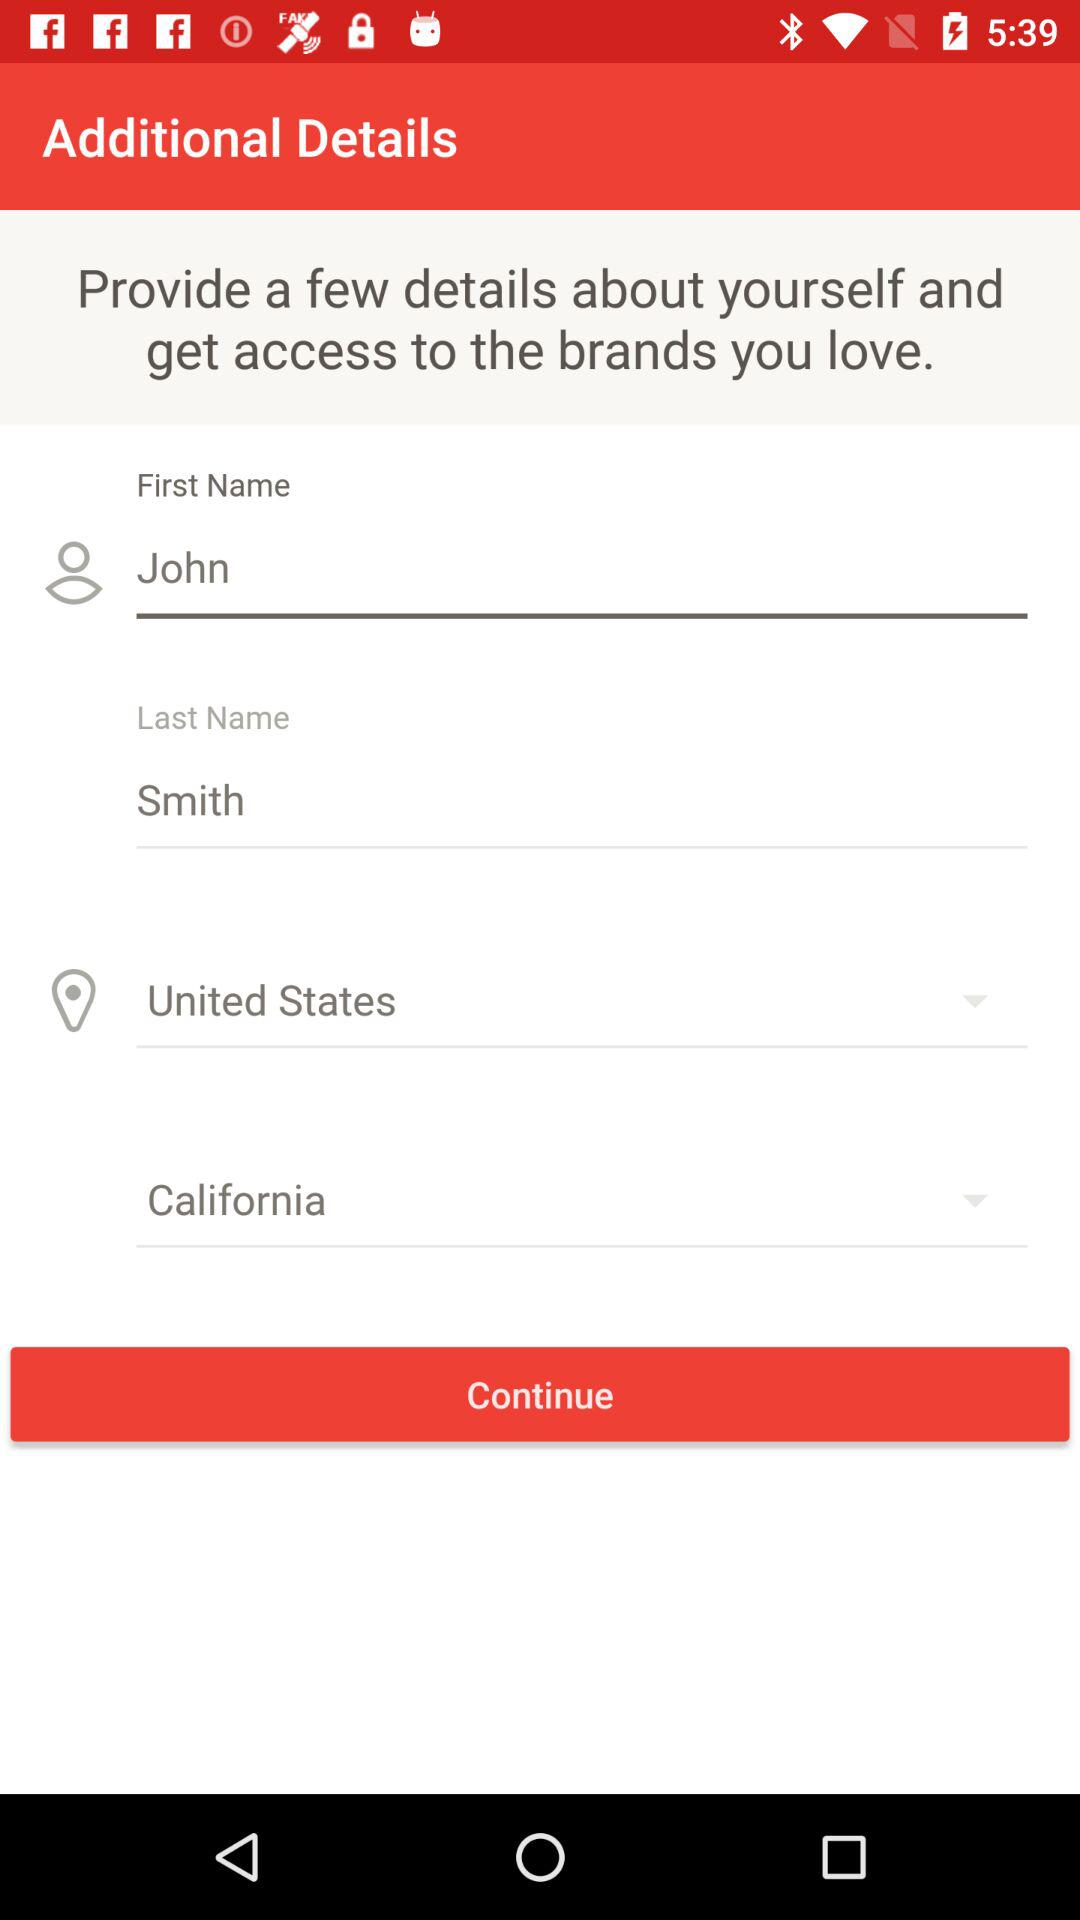What is the name? The name is "John Smith". 